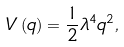<formula> <loc_0><loc_0><loc_500><loc_500>V \left ( q \right ) = \frac { 1 } { 2 } \lambda ^ { 4 } q ^ { 2 } ,</formula> 